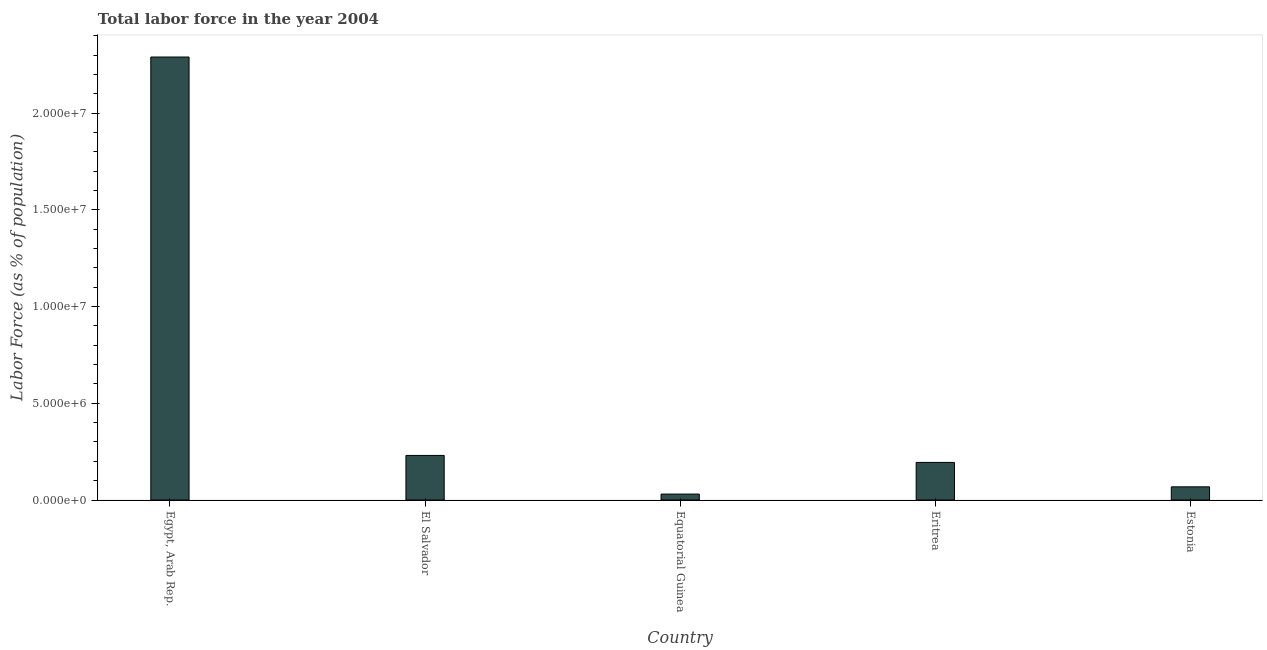Does the graph contain any zero values?
Your response must be concise. No. What is the title of the graph?
Make the answer very short. Total labor force in the year 2004. What is the label or title of the Y-axis?
Provide a short and direct response. Labor Force (as % of population). What is the total labor force in Egypt, Arab Rep.?
Provide a short and direct response. 2.29e+07. Across all countries, what is the maximum total labor force?
Offer a very short reply. 2.29e+07. Across all countries, what is the minimum total labor force?
Your response must be concise. 3.07e+05. In which country was the total labor force maximum?
Offer a very short reply. Egypt, Arab Rep. In which country was the total labor force minimum?
Keep it short and to the point. Equatorial Guinea. What is the sum of the total labor force?
Your answer should be compact. 2.81e+07. What is the difference between the total labor force in Equatorial Guinea and Eritrea?
Make the answer very short. -1.64e+06. What is the average total labor force per country?
Make the answer very short. 5.63e+06. What is the median total labor force?
Provide a short and direct response. 1.94e+06. In how many countries, is the total labor force greater than 8000000 %?
Offer a terse response. 1. What is the ratio of the total labor force in Egypt, Arab Rep. to that in Equatorial Guinea?
Give a very brief answer. 74.63. Is the difference between the total labor force in Equatorial Guinea and Eritrea greater than the difference between any two countries?
Give a very brief answer. No. What is the difference between the highest and the second highest total labor force?
Offer a terse response. 2.06e+07. Is the sum of the total labor force in Equatorial Guinea and Estonia greater than the maximum total labor force across all countries?
Provide a short and direct response. No. What is the difference between the highest and the lowest total labor force?
Provide a short and direct response. 2.26e+07. In how many countries, is the total labor force greater than the average total labor force taken over all countries?
Give a very brief answer. 1. How many bars are there?
Give a very brief answer. 5. Are all the bars in the graph horizontal?
Provide a succinct answer. No. What is the difference between two consecutive major ticks on the Y-axis?
Provide a short and direct response. 5.00e+06. Are the values on the major ticks of Y-axis written in scientific E-notation?
Provide a succinct answer. Yes. What is the Labor Force (as % of population) of Egypt, Arab Rep.?
Keep it short and to the point. 2.29e+07. What is the Labor Force (as % of population) in El Salvador?
Your response must be concise. 2.30e+06. What is the Labor Force (as % of population) of Equatorial Guinea?
Your answer should be very brief. 3.07e+05. What is the Labor Force (as % of population) in Eritrea?
Ensure brevity in your answer.  1.94e+06. What is the Labor Force (as % of population) in Estonia?
Give a very brief answer. 6.80e+05. What is the difference between the Labor Force (as % of population) in Egypt, Arab Rep. and El Salvador?
Provide a succinct answer. 2.06e+07. What is the difference between the Labor Force (as % of population) in Egypt, Arab Rep. and Equatorial Guinea?
Your response must be concise. 2.26e+07. What is the difference between the Labor Force (as % of population) in Egypt, Arab Rep. and Eritrea?
Your answer should be compact. 2.10e+07. What is the difference between the Labor Force (as % of population) in Egypt, Arab Rep. and Estonia?
Keep it short and to the point. 2.22e+07. What is the difference between the Labor Force (as % of population) in El Salvador and Equatorial Guinea?
Keep it short and to the point. 2.00e+06. What is the difference between the Labor Force (as % of population) in El Salvador and Eritrea?
Ensure brevity in your answer.  3.61e+05. What is the difference between the Labor Force (as % of population) in El Salvador and Estonia?
Offer a very short reply. 1.62e+06. What is the difference between the Labor Force (as % of population) in Equatorial Guinea and Eritrea?
Your response must be concise. -1.64e+06. What is the difference between the Labor Force (as % of population) in Equatorial Guinea and Estonia?
Make the answer very short. -3.74e+05. What is the difference between the Labor Force (as % of population) in Eritrea and Estonia?
Provide a succinct answer. 1.26e+06. What is the ratio of the Labor Force (as % of population) in Egypt, Arab Rep. to that in El Salvador?
Make the answer very short. 9.94. What is the ratio of the Labor Force (as % of population) in Egypt, Arab Rep. to that in Equatorial Guinea?
Make the answer very short. 74.63. What is the ratio of the Labor Force (as % of population) in Egypt, Arab Rep. to that in Eritrea?
Offer a very short reply. 11.78. What is the ratio of the Labor Force (as % of population) in Egypt, Arab Rep. to that in Estonia?
Offer a terse response. 33.66. What is the ratio of the Labor Force (as % of population) in El Salvador to that in Equatorial Guinea?
Provide a short and direct response. 7.51. What is the ratio of the Labor Force (as % of population) in El Salvador to that in Eritrea?
Your response must be concise. 1.19. What is the ratio of the Labor Force (as % of population) in El Salvador to that in Estonia?
Ensure brevity in your answer.  3.39. What is the ratio of the Labor Force (as % of population) in Equatorial Guinea to that in Eritrea?
Your answer should be compact. 0.16. What is the ratio of the Labor Force (as % of population) in Equatorial Guinea to that in Estonia?
Ensure brevity in your answer.  0.45. What is the ratio of the Labor Force (as % of population) in Eritrea to that in Estonia?
Your answer should be very brief. 2.86. 